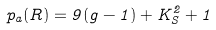Convert formula to latex. <formula><loc_0><loc_0><loc_500><loc_500>p _ { a } ( R ) = 9 ( g - 1 ) + K _ { S } ^ { 2 } + 1</formula> 